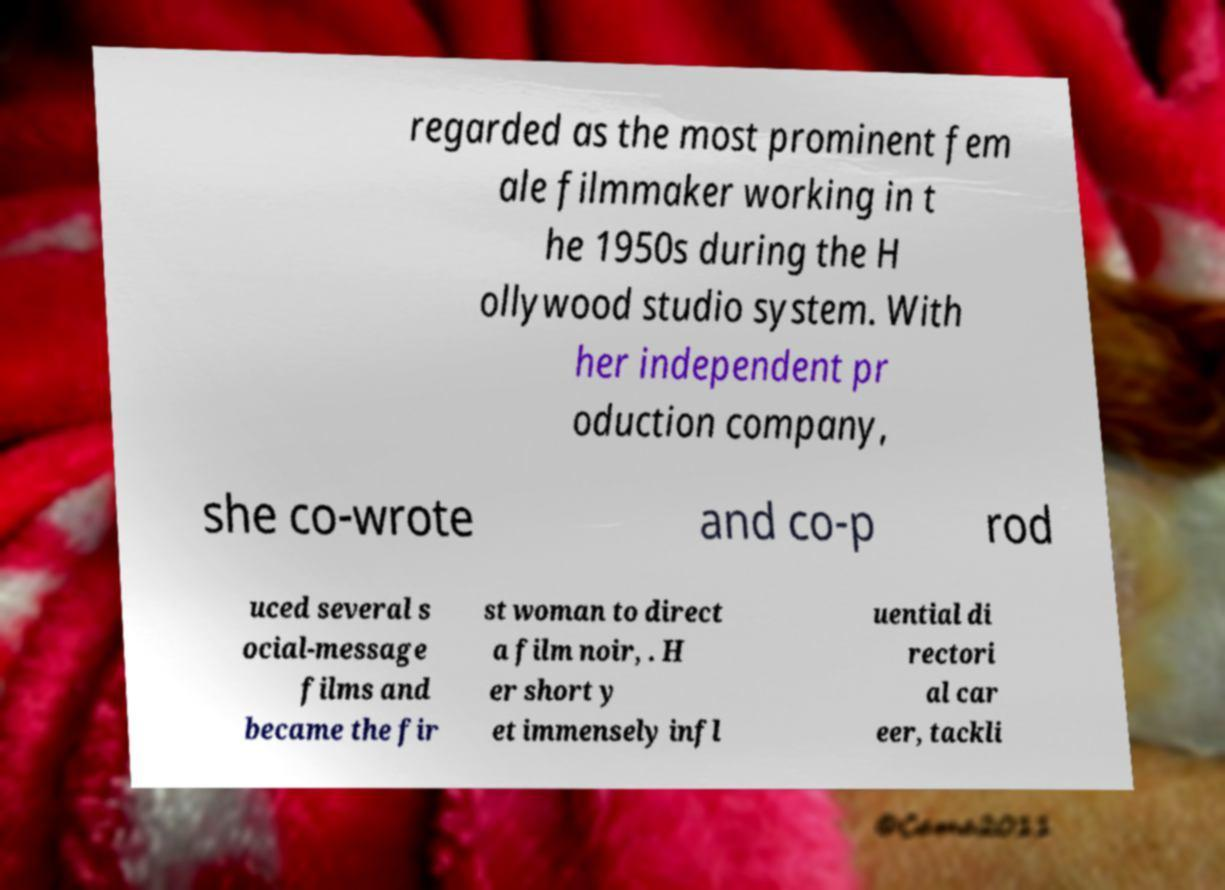There's text embedded in this image that I need extracted. Can you transcribe it verbatim? regarded as the most prominent fem ale filmmaker working in t he 1950s during the H ollywood studio system. With her independent pr oduction company, she co-wrote and co-p rod uced several s ocial-message films and became the fir st woman to direct a film noir, . H er short y et immensely infl uential di rectori al car eer, tackli 